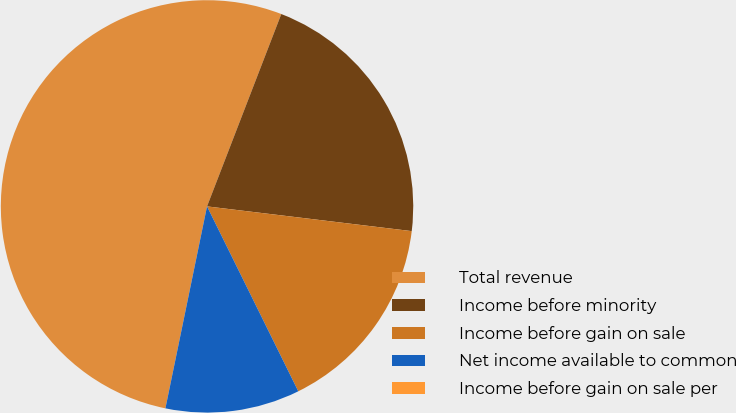Convert chart. <chart><loc_0><loc_0><loc_500><loc_500><pie_chart><fcel>Total revenue<fcel>Income before minority<fcel>Income before gain on sale<fcel>Net income available to common<fcel>Income before gain on sale per<nl><fcel>52.63%<fcel>21.05%<fcel>15.79%<fcel>10.53%<fcel>0.0%<nl></chart> 